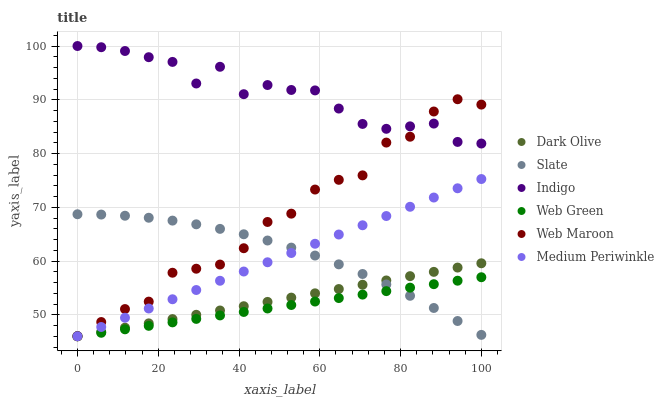Does Web Green have the minimum area under the curve?
Answer yes or no. Yes. Does Indigo have the maximum area under the curve?
Answer yes or no. Yes. Does Medium Periwinkle have the minimum area under the curve?
Answer yes or no. No. Does Medium Periwinkle have the maximum area under the curve?
Answer yes or no. No. Is Dark Olive the smoothest?
Answer yes or no. Yes. Is Indigo the roughest?
Answer yes or no. Yes. Is Medium Periwinkle the smoothest?
Answer yes or no. No. Is Medium Periwinkle the roughest?
Answer yes or no. No. Does Medium Periwinkle have the lowest value?
Answer yes or no. Yes. Does Slate have the lowest value?
Answer yes or no. No. Does Indigo have the highest value?
Answer yes or no. Yes. Does Medium Periwinkle have the highest value?
Answer yes or no. No. Is Medium Periwinkle less than Indigo?
Answer yes or no. Yes. Is Indigo greater than Dark Olive?
Answer yes or no. Yes. Does Medium Periwinkle intersect Web Maroon?
Answer yes or no. Yes. Is Medium Periwinkle less than Web Maroon?
Answer yes or no. No. Is Medium Periwinkle greater than Web Maroon?
Answer yes or no. No. Does Medium Periwinkle intersect Indigo?
Answer yes or no. No. 